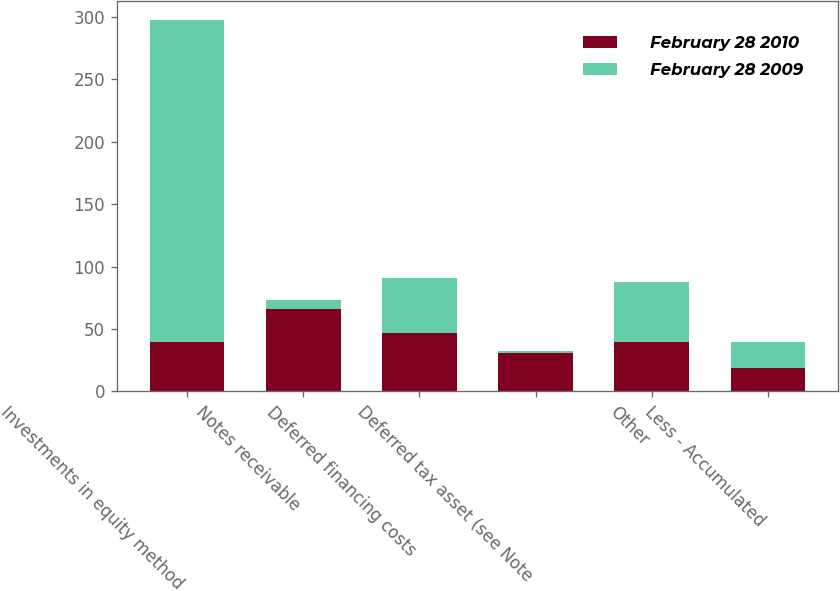Convert chart. <chart><loc_0><loc_0><loc_500><loc_500><stacked_bar_chart><ecel><fcel>Investments in equity method<fcel>Notes receivable<fcel>Deferred financing costs<fcel>Deferred tax asset (see Note<fcel>Other<fcel>Less - Accumulated<nl><fcel>February 28 2010<fcel>39.4<fcel>65.7<fcel>47.1<fcel>30.8<fcel>39.4<fcel>19.1<nl><fcel>February 28 2009<fcel>258.1<fcel>7.4<fcel>44<fcel>1.7<fcel>48.1<fcel>20.4<nl></chart> 